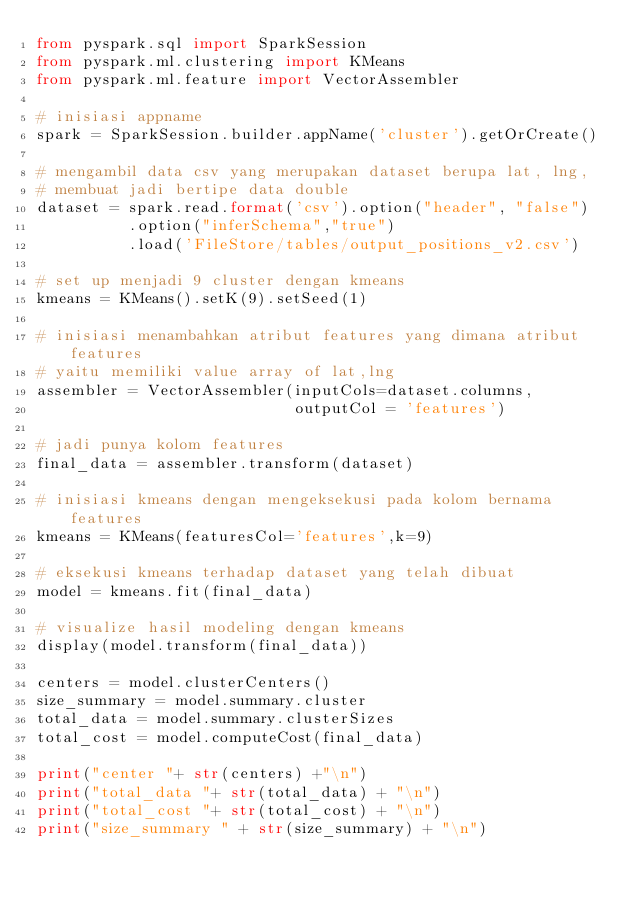<code> <loc_0><loc_0><loc_500><loc_500><_Python_>from pyspark.sql import SparkSession
from pyspark.ml.clustering import KMeans
from pyspark.ml.feature import VectorAssembler

# inisiasi appname
spark = SparkSession.builder.appName('cluster').getOrCreate()

# mengambil data csv yang merupakan dataset berupa lat, lng, 
# membuat jadi bertipe data double
dataset = spark.read.format('csv').option("header", "false")
          .option("inferSchema","true")
          .load('FileStore/tables/output_positions_v2.csv')

# set up menjadi 9 cluster dengan kmeans
kmeans = KMeans().setK(9).setSeed(1)

# inisiasi menambahkan atribut features yang dimana atribut features 
# yaitu memiliki value array of lat,lng
assembler = VectorAssembler(inputCols=dataset.columns, 
                            outputCol = 'features')

# jadi punya kolom features
final_data = assembler.transform(dataset)

# inisiasi kmeans dengan mengeksekusi pada kolom bernama features
kmeans = KMeans(featuresCol='features',k=9)

# eksekusi kmeans terhadap dataset yang telah dibuat
model = kmeans.fit(final_data)

# visualize hasil modeling dengan kmeans
display(model.transform(final_data))

centers = model.clusterCenters()
size_summary = model.summary.cluster
total_data = model.summary.clusterSizes
total_cost = model.computeCost(final_data)

print("center "+ str(centers) +"\n")
print("total_data "+ str(total_data) + "\n")
print("total_cost "+ str(total_cost) + "\n")
print("size_summary " + str(size_summary) + "\n")</code> 